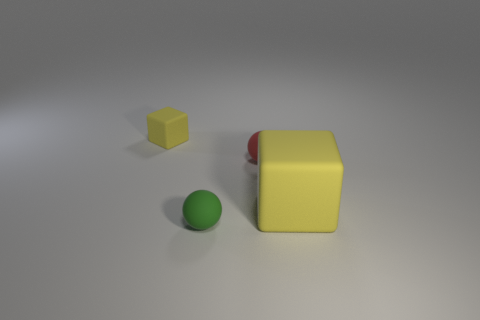Add 3 tiny green rubber cubes. How many objects exist? 7 Subtract 1 spheres. How many spheres are left? 1 Subtract all green balls. How many balls are left? 1 Subtract 0 gray cylinders. How many objects are left? 4 Subtract all red balls. Subtract all green cylinders. How many balls are left? 1 Subtract all red cylinders. How many red balls are left? 1 Subtract all blue objects. Subtract all small red matte things. How many objects are left? 3 Add 2 yellow objects. How many yellow objects are left? 4 Add 2 small red rubber spheres. How many small red rubber spheres exist? 3 